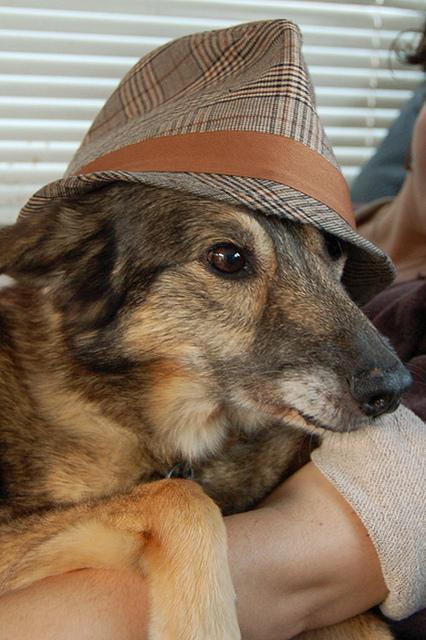How many trains are there?
Give a very brief answer. 0. 